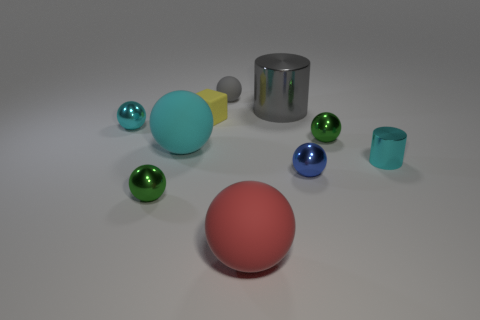How many cyan objects are either large metallic cylinders or matte objects?
Offer a very short reply. 1. The large thing that is both behind the large red matte sphere and to the left of the big gray metal object is what color?
Keep it short and to the point. Cyan. Do the sphere behind the large metallic cylinder and the tiny green thing on the right side of the big cylinder have the same material?
Your answer should be compact. No. Is the number of small rubber balls behind the gray matte ball greater than the number of tiny gray objects that are on the right side of the large cyan thing?
Make the answer very short. No. What is the shape of the cyan metal object that is the same size as the cyan metal cylinder?
Your response must be concise. Sphere. How many things are small yellow blocks or small balls in front of the tiny cyan cylinder?
Give a very brief answer. 3. Does the big metal thing have the same color as the tiny metal cylinder?
Your answer should be very brief. No. How many small matte things are to the right of the yellow block?
Provide a succinct answer. 1. There is another big object that is made of the same material as the blue object; what is its color?
Give a very brief answer. Gray. How many metallic objects are either tiny cylinders or small spheres?
Ensure brevity in your answer.  5. 